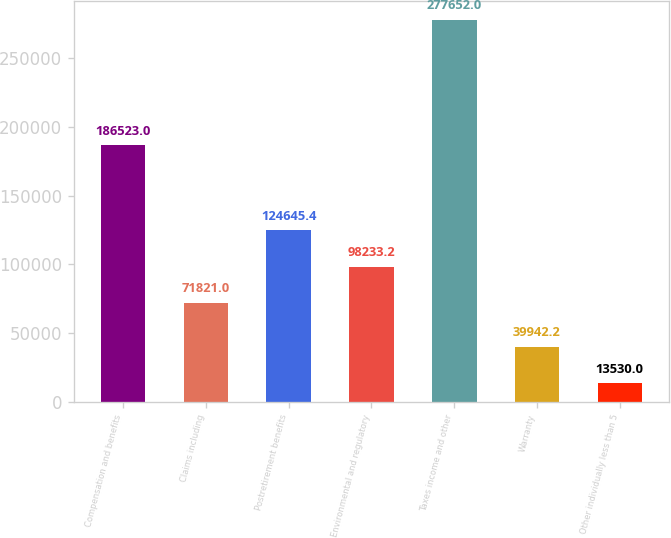Convert chart to OTSL. <chart><loc_0><loc_0><loc_500><loc_500><bar_chart><fcel>Compensation and benefits<fcel>Claims including<fcel>Postretirement benefits<fcel>Environmental and regulatory<fcel>Taxes income and other<fcel>Warranty<fcel>Other individually less than 5<nl><fcel>186523<fcel>71821<fcel>124645<fcel>98233.2<fcel>277652<fcel>39942.2<fcel>13530<nl></chart> 